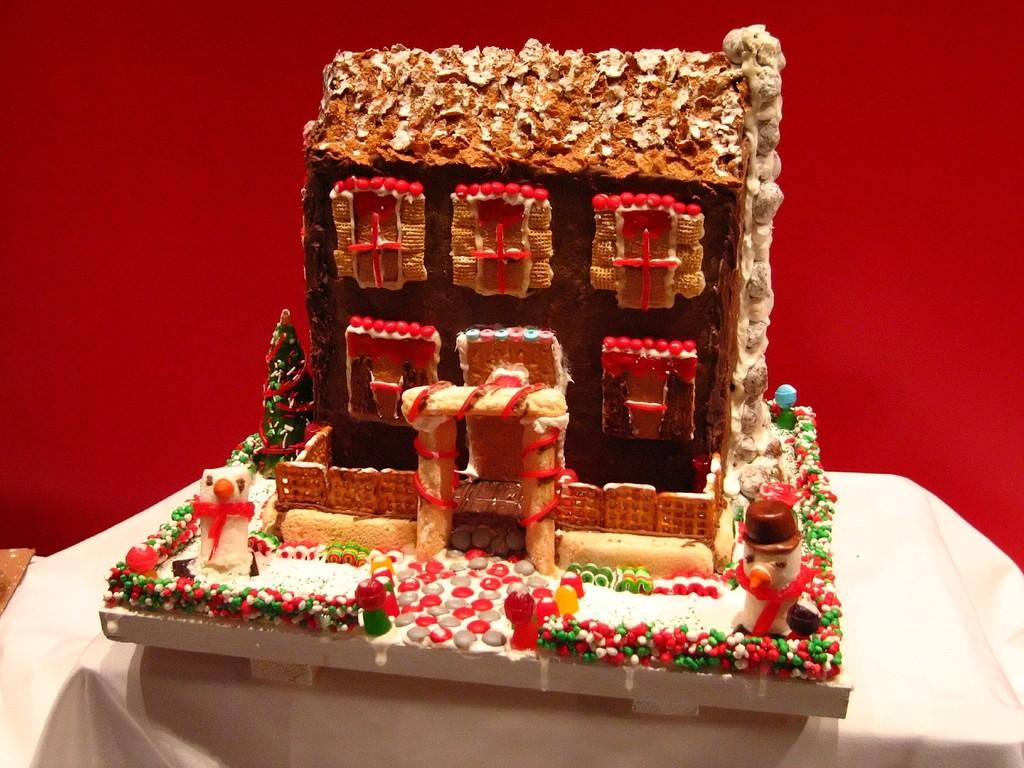What is the main subject of the image? The main subject of the image is a toy house. What is unique about this toy house? The toy house is made with several food items. What type of dress is the toy house wearing in the image? There is no dress present in the image, as the subject is a toy house made with food items. 